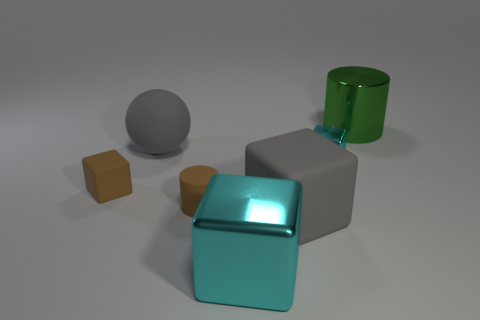Add 2 large cyan metal cubes. How many objects exist? 9 Subtract all cylinders. How many objects are left? 5 Subtract 0 blue balls. How many objects are left? 7 Subtract all small brown cubes. Subtract all big objects. How many objects are left? 2 Add 1 large objects. How many large objects are left? 5 Add 5 brown cylinders. How many brown cylinders exist? 6 